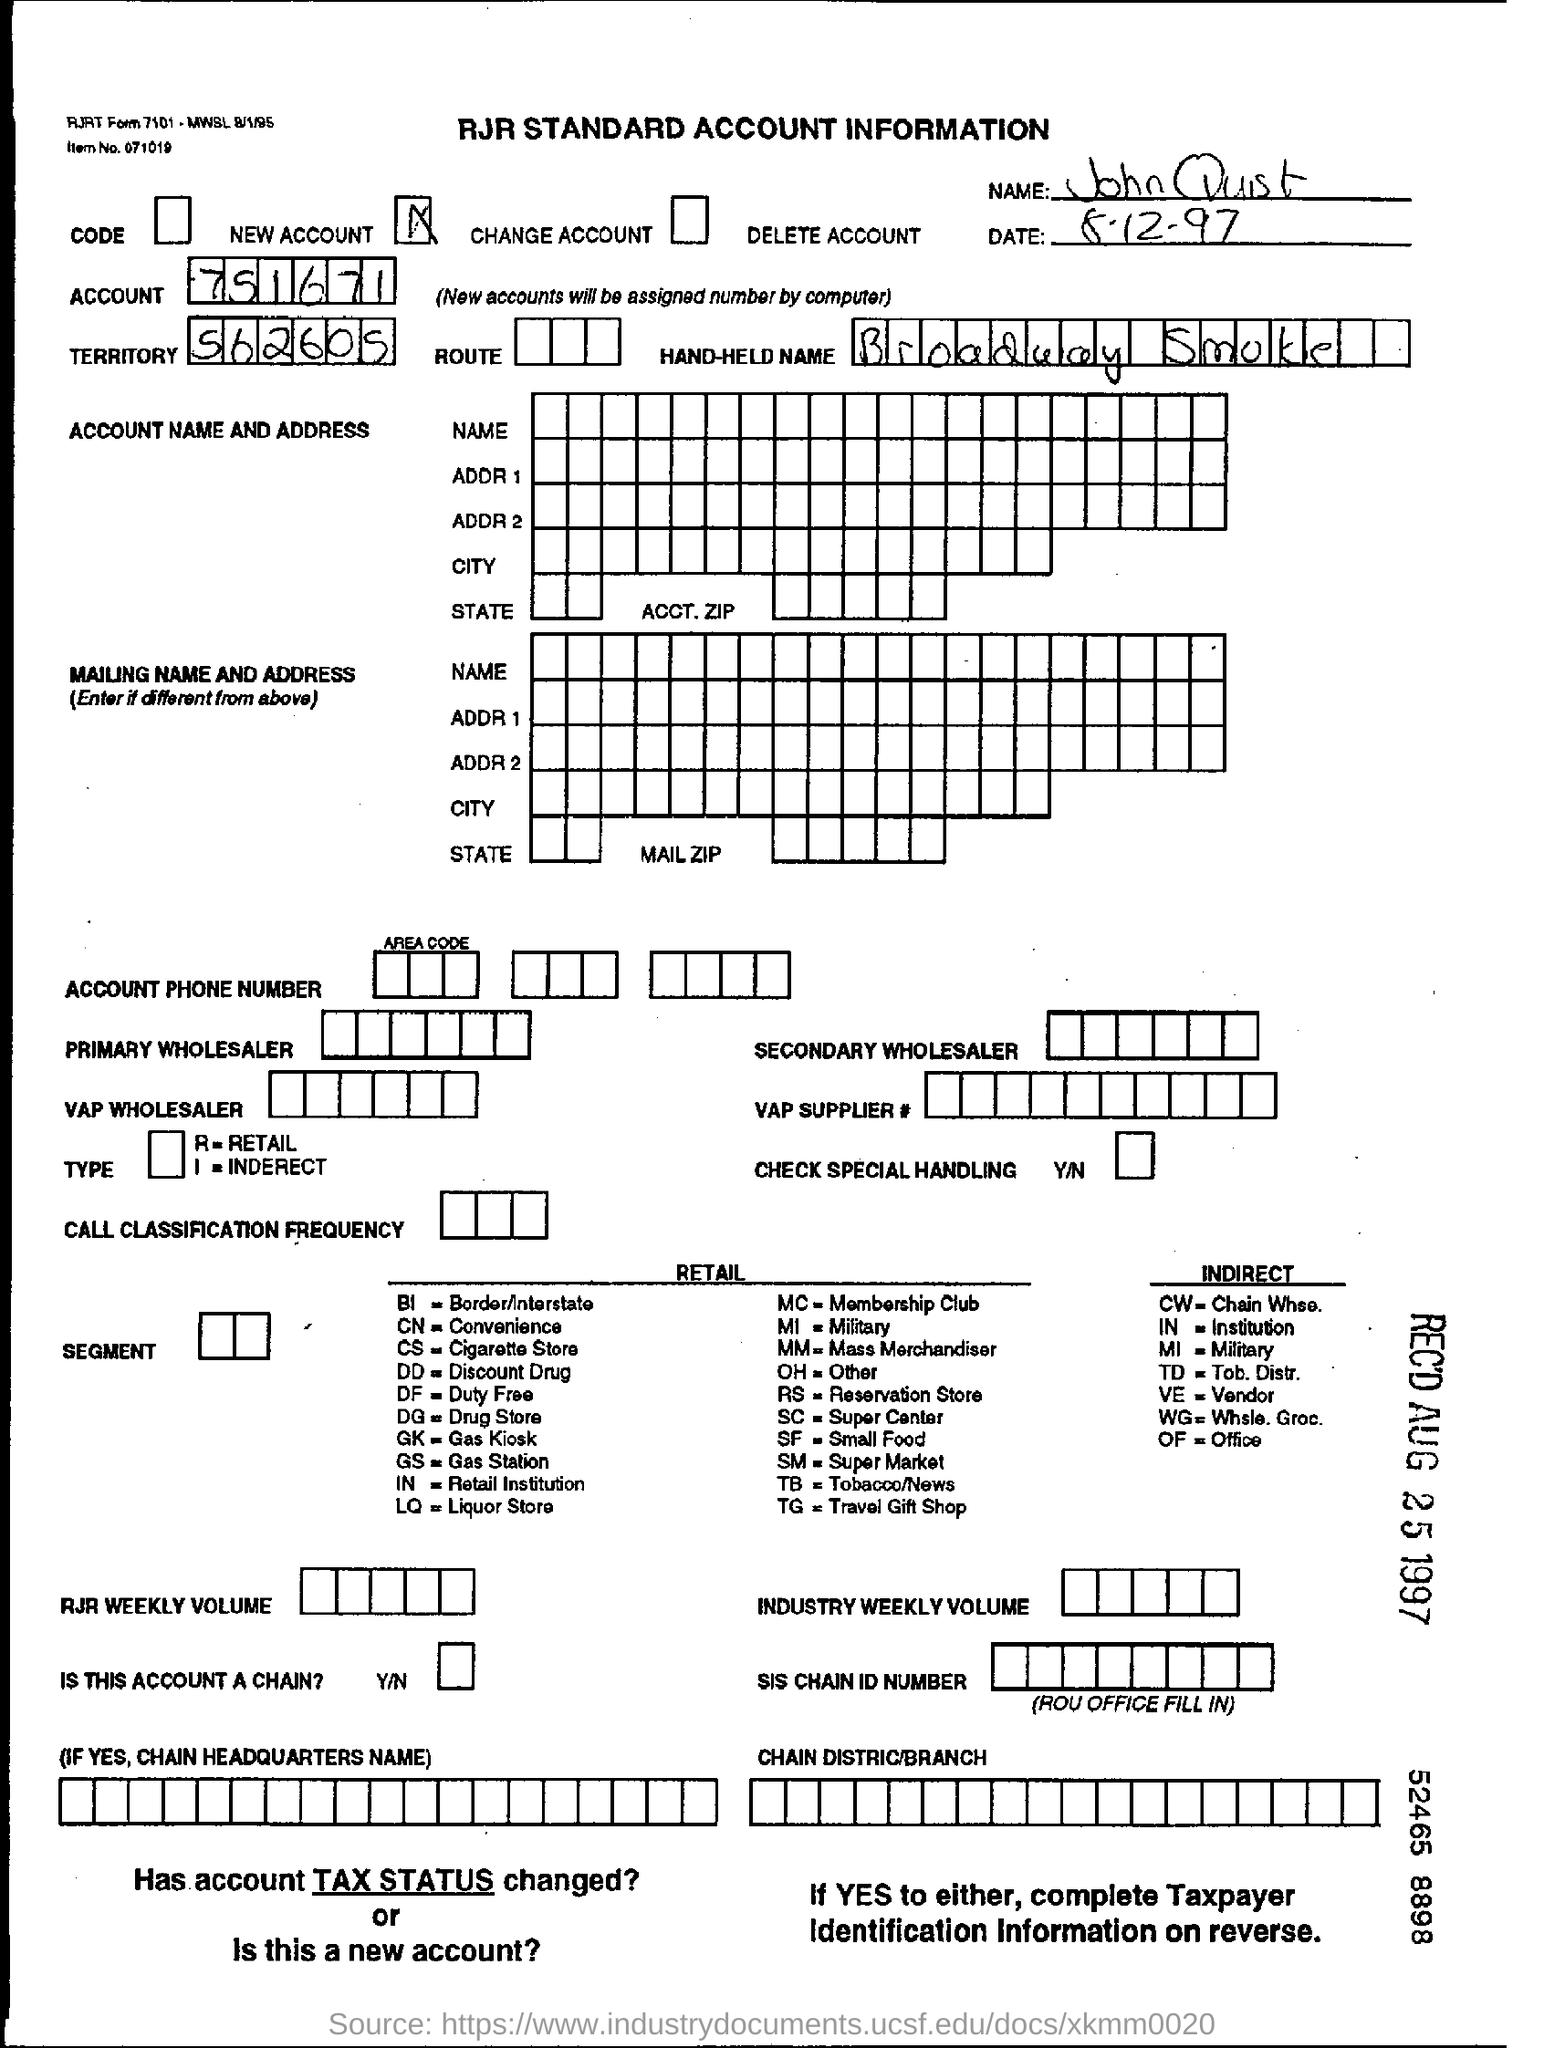List a handful of essential elements in this visual. John Quist is the name mentioned in the form. The territory specified in the form is 562605... The account number provided in the form is 751671... The date mentioned in the form is 8-12-97. 